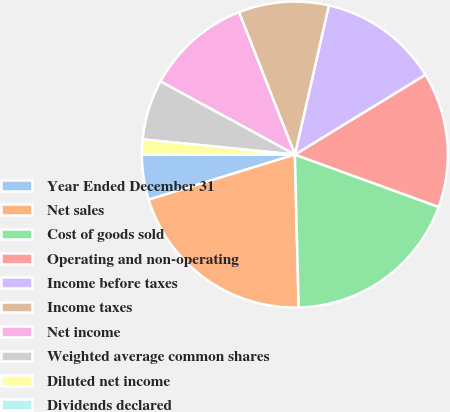Convert chart to OTSL. <chart><loc_0><loc_0><loc_500><loc_500><pie_chart><fcel>Year Ended December 31<fcel>Net sales<fcel>Cost of goods sold<fcel>Operating and non-operating<fcel>Income before taxes<fcel>Income taxes<fcel>Net income<fcel>Weighted average common shares<fcel>Diluted net income<fcel>Dividends declared<nl><fcel>4.76%<fcel>20.63%<fcel>19.05%<fcel>14.29%<fcel>12.7%<fcel>9.52%<fcel>11.11%<fcel>6.35%<fcel>1.59%<fcel>0.0%<nl></chart> 